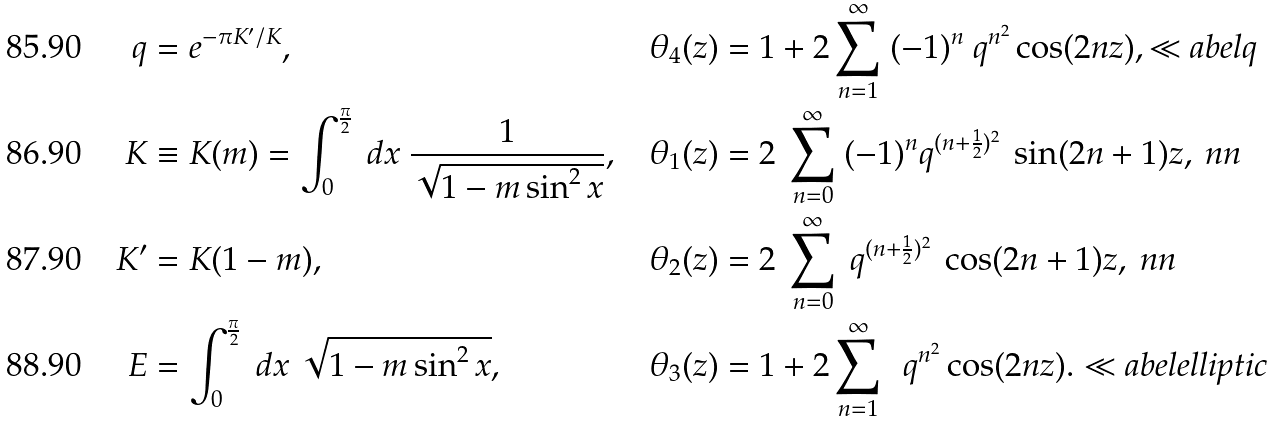<formula> <loc_0><loc_0><loc_500><loc_500>q & = e ^ { - \pi K ^ { \prime } / K } , & \theta _ { 4 } ( z ) & = 1 + 2 \sum _ { n = 1 } ^ { \infty } \ ( - 1 ) ^ { n } \ q ^ { n ^ { 2 } } \cos ( 2 n z ) , \ll a b e l { q } \\ K & \equiv K ( m ) = \int _ { 0 } ^ { \frac { \pi } { 2 } } \ d x \ \frac { 1 } { \sqrt { 1 - m \sin ^ { 2 } x } } , & \theta _ { 1 } ( z ) & = 2 \ \sum _ { n = 0 } ^ { \infty } \ ( - 1 ) ^ { n } q ^ { ( n + \frac { 1 } { 2 } ) ^ { 2 } } \ \sin ( 2 n + 1 ) z , \ n n \\ K ^ { \prime } & = K ( 1 - m ) , & \theta _ { 2 } ( z ) & = 2 \ \sum _ { n = 0 } ^ { \infty } \ q ^ { ( n + \frac { 1 } { 2 } ) ^ { 2 } } \ \cos ( 2 n + 1 ) z , \ n n \\ E & = \int _ { 0 } ^ { \frac { \pi } { 2 } } \ d x \ { \sqrt { 1 - m \sin ^ { 2 } x } } , & \theta _ { 3 } ( z ) & = 1 + 2 \sum _ { n = 1 } ^ { \infty } \ \ q ^ { n ^ { 2 } } \cos ( 2 n z ) . \ll a b e l { e l l i p t i c }</formula> 